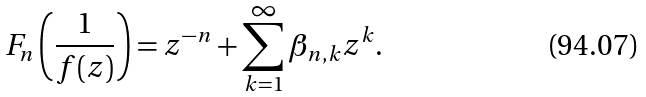<formula> <loc_0><loc_0><loc_500><loc_500>F _ { n } \left ( \frac { 1 } { f ( z ) } \right ) = z ^ { - n } + \sum _ { k = 1 } ^ { \infty } \beta _ { n , k } z ^ { k } .</formula> 